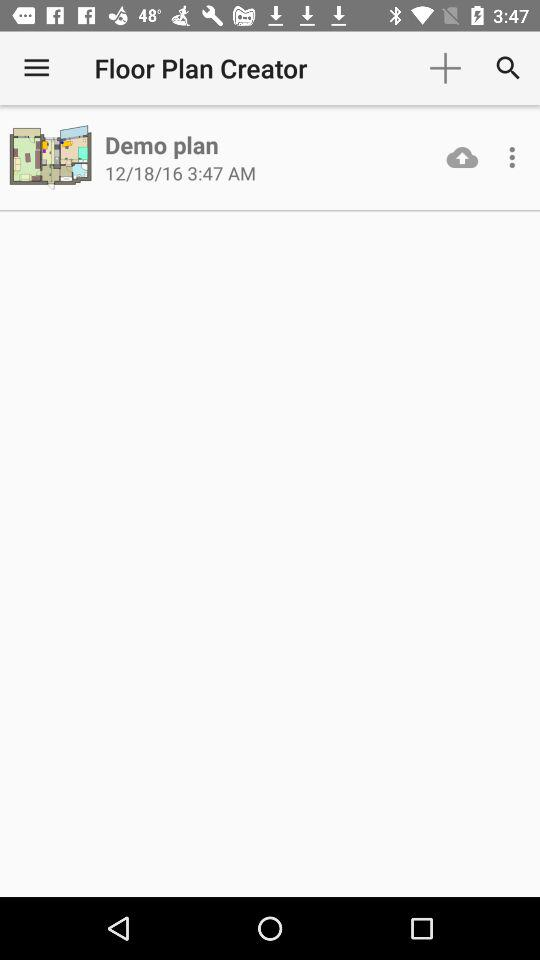What is the time? The time is 3:47 AM. 